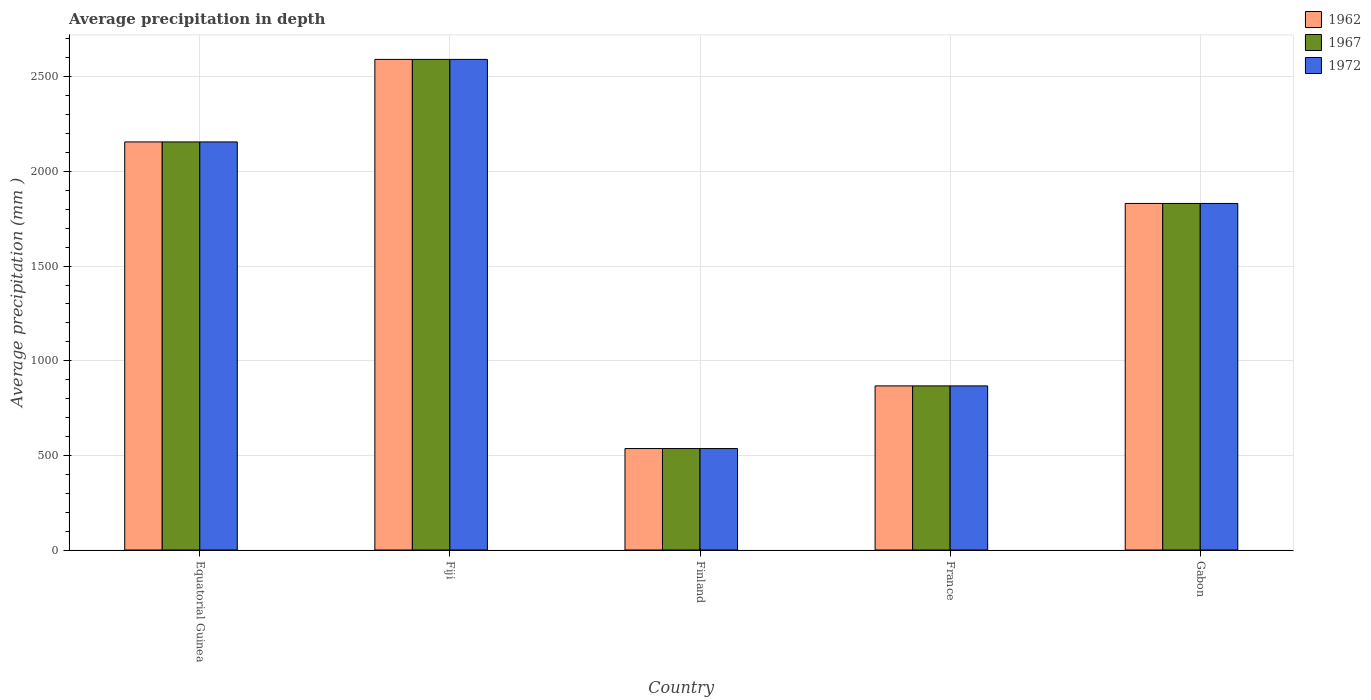How many different coloured bars are there?
Your response must be concise. 3. Are the number of bars per tick equal to the number of legend labels?
Make the answer very short. Yes. How many bars are there on the 1st tick from the left?
Ensure brevity in your answer.  3. How many bars are there on the 1st tick from the right?
Your answer should be compact. 3. What is the label of the 3rd group of bars from the left?
Provide a succinct answer. Finland. What is the average precipitation in 1967 in Finland?
Make the answer very short. 536. Across all countries, what is the maximum average precipitation in 1972?
Your answer should be very brief. 2592. Across all countries, what is the minimum average precipitation in 1972?
Your answer should be very brief. 536. In which country was the average precipitation in 1967 maximum?
Make the answer very short. Fiji. What is the total average precipitation in 1972 in the graph?
Ensure brevity in your answer.  7982. What is the difference between the average precipitation in 1967 in Fiji and that in Gabon?
Provide a succinct answer. 761. What is the difference between the average precipitation in 1972 in France and the average precipitation in 1962 in Equatorial Guinea?
Your response must be concise. -1289. What is the average average precipitation in 1972 per country?
Your answer should be compact. 1596.4. In how many countries, is the average precipitation in 1972 greater than 500 mm?
Provide a short and direct response. 5. What is the ratio of the average precipitation in 1962 in Equatorial Guinea to that in Fiji?
Your response must be concise. 0.83. Is the average precipitation in 1967 in France less than that in Gabon?
Your answer should be very brief. Yes. Is the difference between the average precipitation in 1967 in Fiji and Gabon greater than the difference between the average precipitation in 1962 in Fiji and Gabon?
Offer a very short reply. No. What is the difference between the highest and the second highest average precipitation in 1972?
Offer a terse response. 436. What is the difference between the highest and the lowest average precipitation in 1972?
Keep it short and to the point. 2056. What does the 3rd bar from the left in Fiji represents?
Make the answer very short. 1972. Are all the bars in the graph horizontal?
Give a very brief answer. No. Are the values on the major ticks of Y-axis written in scientific E-notation?
Your answer should be compact. No. Does the graph contain any zero values?
Give a very brief answer. No. Does the graph contain grids?
Provide a succinct answer. Yes. Where does the legend appear in the graph?
Keep it short and to the point. Top right. How many legend labels are there?
Provide a succinct answer. 3. How are the legend labels stacked?
Ensure brevity in your answer.  Vertical. What is the title of the graph?
Your response must be concise. Average precipitation in depth. What is the label or title of the Y-axis?
Give a very brief answer. Average precipitation (mm ). What is the Average precipitation (mm ) of 1962 in Equatorial Guinea?
Make the answer very short. 2156. What is the Average precipitation (mm ) of 1967 in Equatorial Guinea?
Give a very brief answer. 2156. What is the Average precipitation (mm ) of 1972 in Equatorial Guinea?
Make the answer very short. 2156. What is the Average precipitation (mm ) of 1962 in Fiji?
Make the answer very short. 2592. What is the Average precipitation (mm ) of 1967 in Fiji?
Offer a very short reply. 2592. What is the Average precipitation (mm ) of 1972 in Fiji?
Give a very brief answer. 2592. What is the Average precipitation (mm ) in 1962 in Finland?
Provide a short and direct response. 536. What is the Average precipitation (mm ) in 1967 in Finland?
Provide a succinct answer. 536. What is the Average precipitation (mm ) of 1972 in Finland?
Provide a short and direct response. 536. What is the Average precipitation (mm ) in 1962 in France?
Give a very brief answer. 867. What is the Average precipitation (mm ) in 1967 in France?
Keep it short and to the point. 867. What is the Average precipitation (mm ) of 1972 in France?
Keep it short and to the point. 867. What is the Average precipitation (mm ) in 1962 in Gabon?
Ensure brevity in your answer.  1831. What is the Average precipitation (mm ) in 1967 in Gabon?
Give a very brief answer. 1831. What is the Average precipitation (mm ) in 1972 in Gabon?
Your response must be concise. 1831. Across all countries, what is the maximum Average precipitation (mm ) in 1962?
Offer a terse response. 2592. Across all countries, what is the maximum Average precipitation (mm ) in 1967?
Your answer should be compact. 2592. Across all countries, what is the maximum Average precipitation (mm ) in 1972?
Ensure brevity in your answer.  2592. Across all countries, what is the minimum Average precipitation (mm ) of 1962?
Provide a short and direct response. 536. Across all countries, what is the minimum Average precipitation (mm ) of 1967?
Provide a succinct answer. 536. Across all countries, what is the minimum Average precipitation (mm ) of 1972?
Provide a short and direct response. 536. What is the total Average precipitation (mm ) of 1962 in the graph?
Provide a short and direct response. 7982. What is the total Average precipitation (mm ) of 1967 in the graph?
Ensure brevity in your answer.  7982. What is the total Average precipitation (mm ) of 1972 in the graph?
Offer a terse response. 7982. What is the difference between the Average precipitation (mm ) in 1962 in Equatorial Guinea and that in Fiji?
Ensure brevity in your answer.  -436. What is the difference between the Average precipitation (mm ) in 1967 in Equatorial Guinea and that in Fiji?
Provide a short and direct response. -436. What is the difference between the Average precipitation (mm ) in 1972 in Equatorial Guinea and that in Fiji?
Offer a very short reply. -436. What is the difference between the Average precipitation (mm ) of 1962 in Equatorial Guinea and that in Finland?
Your response must be concise. 1620. What is the difference between the Average precipitation (mm ) of 1967 in Equatorial Guinea and that in Finland?
Provide a succinct answer. 1620. What is the difference between the Average precipitation (mm ) of 1972 in Equatorial Guinea and that in Finland?
Provide a short and direct response. 1620. What is the difference between the Average precipitation (mm ) of 1962 in Equatorial Guinea and that in France?
Provide a succinct answer. 1289. What is the difference between the Average precipitation (mm ) in 1967 in Equatorial Guinea and that in France?
Your response must be concise. 1289. What is the difference between the Average precipitation (mm ) in 1972 in Equatorial Guinea and that in France?
Offer a terse response. 1289. What is the difference between the Average precipitation (mm ) in 1962 in Equatorial Guinea and that in Gabon?
Offer a very short reply. 325. What is the difference between the Average precipitation (mm ) in 1967 in Equatorial Guinea and that in Gabon?
Offer a terse response. 325. What is the difference between the Average precipitation (mm ) of 1972 in Equatorial Guinea and that in Gabon?
Provide a short and direct response. 325. What is the difference between the Average precipitation (mm ) of 1962 in Fiji and that in Finland?
Offer a terse response. 2056. What is the difference between the Average precipitation (mm ) in 1967 in Fiji and that in Finland?
Ensure brevity in your answer.  2056. What is the difference between the Average precipitation (mm ) of 1972 in Fiji and that in Finland?
Give a very brief answer. 2056. What is the difference between the Average precipitation (mm ) in 1962 in Fiji and that in France?
Give a very brief answer. 1725. What is the difference between the Average precipitation (mm ) in 1967 in Fiji and that in France?
Ensure brevity in your answer.  1725. What is the difference between the Average precipitation (mm ) in 1972 in Fiji and that in France?
Provide a short and direct response. 1725. What is the difference between the Average precipitation (mm ) of 1962 in Fiji and that in Gabon?
Keep it short and to the point. 761. What is the difference between the Average precipitation (mm ) in 1967 in Fiji and that in Gabon?
Provide a short and direct response. 761. What is the difference between the Average precipitation (mm ) in 1972 in Fiji and that in Gabon?
Provide a succinct answer. 761. What is the difference between the Average precipitation (mm ) of 1962 in Finland and that in France?
Ensure brevity in your answer.  -331. What is the difference between the Average precipitation (mm ) in 1967 in Finland and that in France?
Offer a very short reply. -331. What is the difference between the Average precipitation (mm ) of 1972 in Finland and that in France?
Ensure brevity in your answer.  -331. What is the difference between the Average precipitation (mm ) in 1962 in Finland and that in Gabon?
Offer a terse response. -1295. What is the difference between the Average precipitation (mm ) of 1967 in Finland and that in Gabon?
Offer a terse response. -1295. What is the difference between the Average precipitation (mm ) of 1972 in Finland and that in Gabon?
Provide a succinct answer. -1295. What is the difference between the Average precipitation (mm ) in 1962 in France and that in Gabon?
Offer a terse response. -964. What is the difference between the Average precipitation (mm ) of 1967 in France and that in Gabon?
Your answer should be compact. -964. What is the difference between the Average precipitation (mm ) of 1972 in France and that in Gabon?
Keep it short and to the point. -964. What is the difference between the Average precipitation (mm ) of 1962 in Equatorial Guinea and the Average precipitation (mm ) of 1967 in Fiji?
Give a very brief answer. -436. What is the difference between the Average precipitation (mm ) in 1962 in Equatorial Guinea and the Average precipitation (mm ) in 1972 in Fiji?
Offer a terse response. -436. What is the difference between the Average precipitation (mm ) in 1967 in Equatorial Guinea and the Average precipitation (mm ) in 1972 in Fiji?
Make the answer very short. -436. What is the difference between the Average precipitation (mm ) in 1962 in Equatorial Guinea and the Average precipitation (mm ) in 1967 in Finland?
Give a very brief answer. 1620. What is the difference between the Average precipitation (mm ) of 1962 in Equatorial Guinea and the Average precipitation (mm ) of 1972 in Finland?
Give a very brief answer. 1620. What is the difference between the Average precipitation (mm ) of 1967 in Equatorial Guinea and the Average precipitation (mm ) of 1972 in Finland?
Provide a short and direct response. 1620. What is the difference between the Average precipitation (mm ) in 1962 in Equatorial Guinea and the Average precipitation (mm ) in 1967 in France?
Provide a succinct answer. 1289. What is the difference between the Average precipitation (mm ) of 1962 in Equatorial Guinea and the Average precipitation (mm ) of 1972 in France?
Offer a very short reply. 1289. What is the difference between the Average precipitation (mm ) of 1967 in Equatorial Guinea and the Average precipitation (mm ) of 1972 in France?
Offer a terse response. 1289. What is the difference between the Average precipitation (mm ) in 1962 in Equatorial Guinea and the Average precipitation (mm ) in 1967 in Gabon?
Ensure brevity in your answer.  325. What is the difference between the Average precipitation (mm ) of 1962 in Equatorial Guinea and the Average precipitation (mm ) of 1972 in Gabon?
Your answer should be compact. 325. What is the difference between the Average precipitation (mm ) in 1967 in Equatorial Guinea and the Average precipitation (mm ) in 1972 in Gabon?
Keep it short and to the point. 325. What is the difference between the Average precipitation (mm ) of 1962 in Fiji and the Average precipitation (mm ) of 1967 in Finland?
Ensure brevity in your answer.  2056. What is the difference between the Average precipitation (mm ) in 1962 in Fiji and the Average precipitation (mm ) in 1972 in Finland?
Your answer should be very brief. 2056. What is the difference between the Average precipitation (mm ) in 1967 in Fiji and the Average precipitation (mm ) in 1972 in Finland?
Ensure brevity in your answer.  2056. What is the difference between the Average precipitation (mm ) in 1962 in Fiji and the Average precipitation (mm ) in 1967 in France?
Offer a very short reply. 1725. What is the difference between the Average precipitation (mm ) of 1962 in Fiji and the Average precipitation (mm ) of 1972 in France?
Keep it short and to the point. 1725. What is the difference between the Average precipitation (mm ) in 1967 in Fiji and the Average precipitation (mm ) in 1972 in France?
Offer a very short reply. 1725. What is the difference between the Average precipitation (mm ) of 1962 in Fiji and the Average precipitation (mm ) of 1967 in Gabon?
Make the answer very short. 761. What is the difference between the Average precipitation (mm ) in 1962 in Fiji and the Average precipitation (mm ) in 1972 in Gabon?
Offer a very short reply. 761. What is the difference between the Average precipitation (mm ) in 1967 in Fiji and the Average precipitation (mm ) in 1972 in Gabon?
Provide a short and direct response. 761. What is the difference between the Average precipitation (mm ) in 1962 in Finland and the Average precipitation (mm ) in 1967 in France?
Your answer should be very brief. -331. What is the difference between the Average precipitation (mm ) of 1962 in Finland and the Average precipitation (mm ) of 1972 in France?
Ensure brevity in your answer.  -331. What is the difference between the Average precipitation (mm ) of 1967 in Finland and the Average precipitation (mm ) of 1972 in France?
Keep it short and to the point. -331. What is the difference between the Average precipitation (mm ) in 1962 in Finland and the Average precipitation (mm ) in 1967 in Gabon?
Your answer should be compact. -1295. What is the difference between the Average precipitation (mm ) in 1962 in Finland and the Average precipitation (mm ) in 1972 in Gabon?
Make the answer very short. -1295. What is the difference between the Average precipitation (mm ) of 1967 in Finland and the Average precipitation (mm ) of 1972 in Gabon?
Give a very brief answer. -1295. What is the difference between the Average precipitation (mm ) of 1962 in France and the Average precipitation (mm ) of 1967 in Gabon?
Keep it short and to the point. -964. What is the difference between the Average precipitation (mm ) of 1962 in France and the Average precipitation (mm ) of 1972 in Gabon?
Ensure brevity in your answer.  -964. What is the difference between the Average precipitation (mm ) in 1967 in France and the Average precipitation (mm ) in 1972 in Gabon?
Your answer should be compact. -964. What is the average Average precipitation (mm ) in 1962 per country?
Make the answer very short. 1596.4. What is the average Average precipitation (mm ) of 1967 per country?
Keep it short and to the point. 1596.4. What is the average Average precipitation (mm ) in 1972 per country?
Provide a short and direct response. 1596.4. What is the difference between the Average precipitation (mm ) of 1962 and Average precipitation (mm ) of 1967 in Equatorial Guinea?
Make the answer very short. 0. What is the difference between the Average precipitation (mm ) of 1962 and Average precipitation (mm ) of 1967 in Fiji?
Ensure brevity in your answer.  0. What is the difference between the Average precipitation (mm ) in 1962 and Average precipitation (mm ) in 1972 in Finland?
Your answer should be very brief. 0. What is the difference between the Average precipitation (mm ) in 1967 and Average precipitation (mm ) in 1972 in France?
Give a very brief answer. 0. What is the difference between the Average precipitation (mm ) in 1962 and Average precipitation (mm ) in 1967 in Gabon?
Provide a short and direct response. 0. What is the difference between the Average precipitation (mm ) in 1962 and Average precipitation (mm ) in 1972 in Gabon?
Offer a terse response. 0. What is the ratio of the Average precipitation (mm ) of 1962 in Equatorial Guinea to that in Fiji?
Ensure brevity in your answer.  0.83. What is the ratio of the Average precipitation (mm ) in 1967 in Equatorial Guinea to that in Fiji?
Your answer should be compact. 0.83. What is the ratio of the Average precipitation (mm ) of 1972 in Equatorial Guinea to that in Fiji?
Ensure brevity in your answer.  0.83. What is the ratio of the Average precipitation (mm ) in 1962 in Equatorial Guinea to that in Finland?
Your response must be concise. 4.02. What is the ratio of the Average precipitation (mm ) in 1967 in Equatorial Guinea to that in Finland?
Ensure brevity in your answer.  4.02. What is the ratio of the Average precipitation (mm ) in 1972 in Equatorial Guinea to that in Finland?
Provide a succinct answer. 4.02. What is the ratio of the Average precipitation (mm ) in 1962 in Equatorial Guinea to that in France?
Provide a short and direct response. 2.49. What is the ratio of the Average precipitation (mm ) in 1967 in Equatorial Guinea to that in France?
Offer a very short reply. 2.49. What is the ratio of the Average precipitation (mm ) of 1972 in Equatorial Guinea to that in France?
Keep it short and to the point. 2.49. What is the ratio of the Average precipitation (mm ) in 1962 in Equatorial Guinea to that in Gabon?
Provide a short and direct response. 1.18. What is the ratio of the Average precipitation (mm ) in 1967 in Equatorial Guinea to that in Gabon?
Make the answer very short. 1.18. What is the ratio of the Average precipitation (mm ) in 1972 in Equatorial Guinea to that in Gabon?
Your answer should be very brief. 1.18. What is the ratio of the Average precipitation (mm ) of 1962 in Fiji to that in Finland?
Your answer should be very brief. 4.84. What is the ratio of the Average precipitation (mm ) of 1967 in Fiji to that in Finland?
Offer a very short reply. 4.84. What is the ratio of the Average precipitation (mm ) in 1972 in Fiji to that in Finland?
Keep it short and to the point. 4.84. What is the ratio of the Average precipitation (mm ) in 1962 in Fiji to that in France?
Ensure brevity in your answer.  2.99. What is the ratio of the Average precipitation (mm ) of 1967 in Fiji to that in France?
Give a very brief answer. 2.99. What is the ratio of the Average precipitation (mm ) in 1972 in Fiji to that in France?
Provide a short and direct response. 2.99. What is the ratio of the Average precipitation (mm ) in 1962 in Fiji to that in Gabon?
Ensure brevity in your answer.  1.42. What is the ratio of the Average precipitation (mm ) in 1967 in Fiji to that in Gabon?
Make the answer very short. 1.42. What is the ratio of the Average precipitation (mm ) of 1972 in Fiji to that in Gabon?
Ensure brevity in your answer.  1.42. What is the ratio of the Average precipitation (mm ) of 1962 in Finland to that in France?
Your answer should be compact. 0.62. What is the ratio of the Average precipitation (mm ) in 1967 in Finland to that in France?
Your answer should be compact. 0.62. What is the ratio of the Average precipitation (mm ) in 1972 in Finland to that in France?
Offer a very short reply. 0.62. What is the ratio of the Average precipitation (mm ) of 1962 in Finland to that in Gabon?
Keep it short and to the point. 0.29. What is the ratio of the Average precipitation (mm ) of 1967 in Finland to that in Gabon?
Offer a terse response. 0.29. What is the ratio of the Average precipitation (mm ) in 1972 in Finland to that in Gabon?
Ensure brevity in your answer.  0.29. What is the ratio of the Average precipitation (mm ) in 1962 in France to that in Gabon?
Your response must be concise. 0.47. What is the ratio of the Average precipitation (mm ) of 1967 in France to that in Gabon?
Provide a short and direct response. 0.47. What is the ratio of the Average precipitation (mm ) of 1972 in France to that in Gabon?
Your answer should be compact. 0.47. What is the difference between the highest and the second highest Average precipitation (mm ) in 1962?
Provide a short and direct response. 436. What is the difference between the highest and the second highest Average precipitation (mm ) in 1967?
Your answer should be very brief. 436. What is the difference between the highest and the second highest Average precipitation (mm ) of 1972?
Offer a terse response. 436. What is the difference between the highest and the lowest Average precipitation (mm ) in 1962?
Provide a succinct answer. 2056. What is the difference between the highest and the lowest Average precipitation (mm ) in 1967?
Provide a short and direct response. 2056. What is the difference between the highest and the lowest Average precipitation (mm ) of 1972?
Make the answer very short. 2056. 